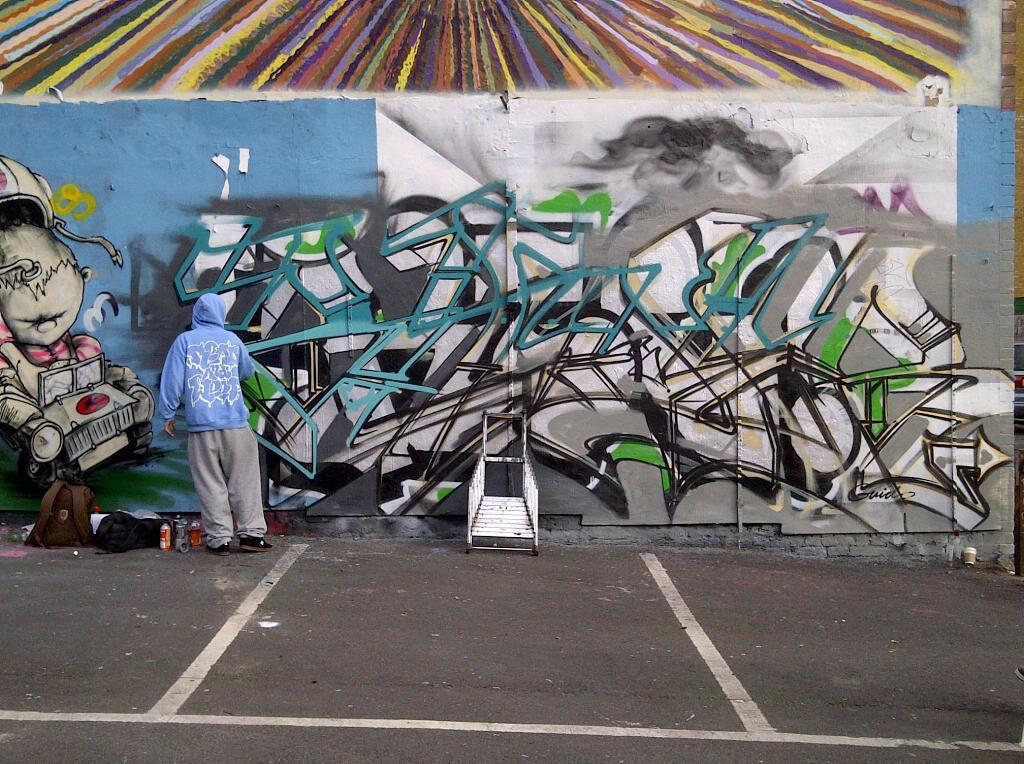How would you summarize this image in a sentence or two? Here we can see graffiti on the wall. In front of this wall there is a person, bottles, bags, and an object. 